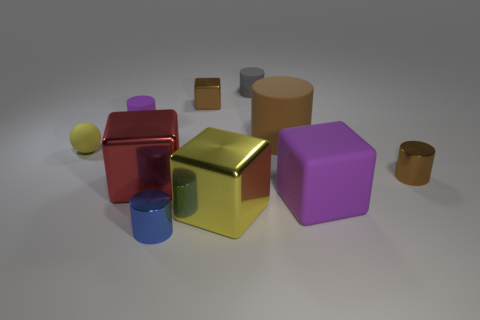There is a purple matte thing behind the big matte block; are there any yellow rubber objects that are behind it?
Ensure brevity in your answer.  No. Are the small blue cylinder and the large brown thing made of the same material?
Offer a terse response. No. There is a small thing that is in front of the large brown cylinder and on the left side of the red metallic thing; what is its shape?
Offer a terse response. Sphere. What size is the metal thing that is left of the tiny metal cylinder that is in front of the large red shiny cube?
Provide a succinct answer. Large. How many other objects have the same shape as the red shiny thing?
Offer a terse response. 3. Does the large matte block have the same color as the small cube?
Make the answer very short. No. Is there any other thing that has the same shape as the small purple object?
Your response must be concise. Yes. Are there any other cylinders of the same color as the large cylinder?
Keep it short and to the point. Yes. Does the small cylinder on the right side of the large cylinder have the same material as the big cylinder right of the tiny gray matte thing?
Your answer should be very brief. No. What is the color of the small metallic cube?
Make the answer very short. Brown. 